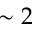Convert formula to latex. <formula><loc_0><loc_0><loc_500><loc_500>\sim 2</formula> 